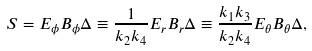Convert formula to latex. <formula><loc_0><loc_0><loc_500><loc_500>S = E _ { \phi } B _ { \phi } \Delta \equiv \frac { 1 } { k _ { 2 } k _ { 4 } } E _ { r } B _ { r } \Delta \equiv \frac { k _ { 1 } k _ { 3 } } { k _ { 2 } k _ { 4 } } E _ { \theta } B _ { \theta } \Delta ,</formula> 